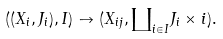Convert formula to latex. <formula><loc_0><loc_0><loc_500><loc_500>( ( X _ { i } , J _ { i } ) , I ) \to ( X _ { i j } , { \coprod } _ { i \in I } J _ { i } \times { i } ) .</formula> 